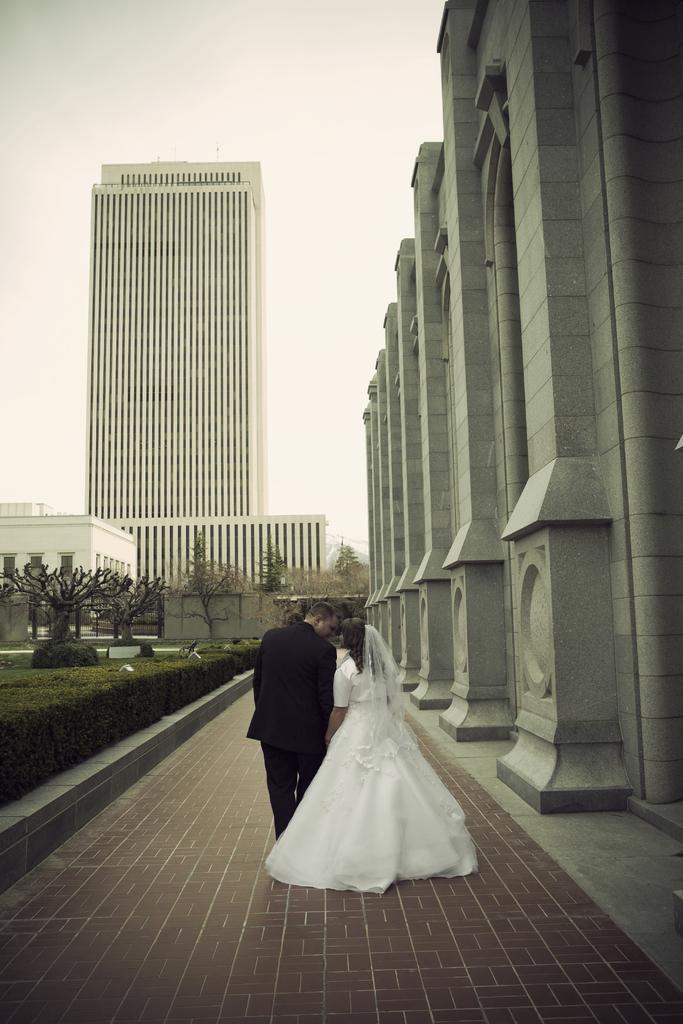In one or two sentences, can you explain what this image depicts? In this image I can see two persons are standing. I can see the left one is wearing black colour dress and the right one is wearing white colour dress. Around them I can see plants, few buildings and number of trees. 